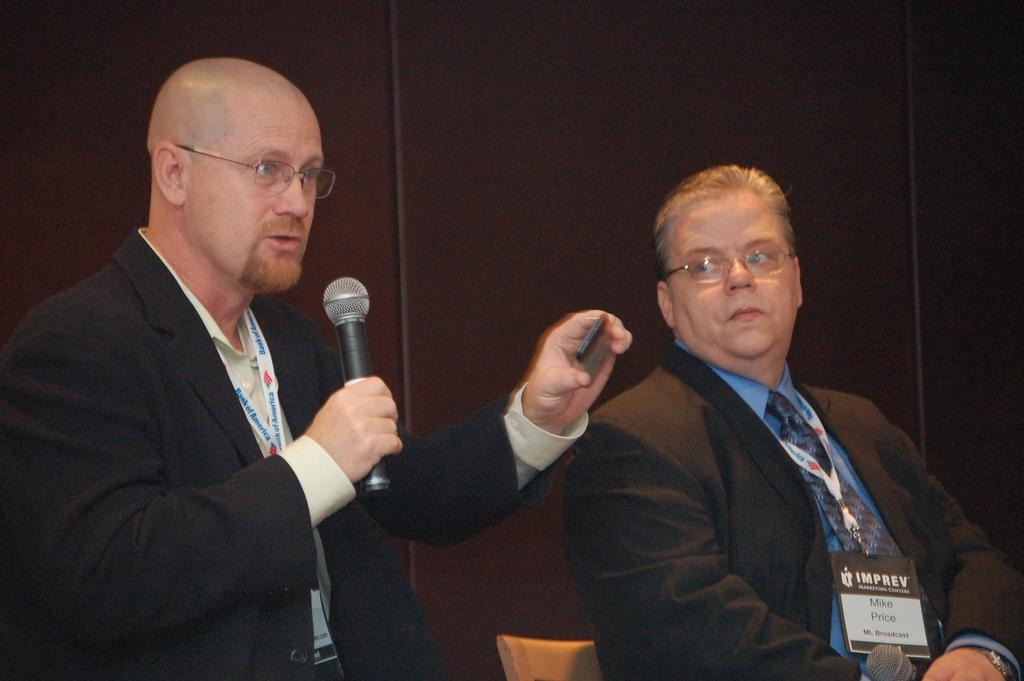How many people are in the image? There are two men in the image. What are the men doing in the image? The men are sitting on chairs. Can you describe what one of the men is holding? One of the men is holding a microphone in his hand. What is the man with the microphone doing? The man with the microphone is speaking. What type of shock can be seen coming from the microphone in the image? There is no shock coming from the microphone in the image; it is simply being held by one of the men. Can you describe the type of ray that is present in the image? There is no ray present in the image; it features two men sitting on chairs, one of whom is holding a microphone. 